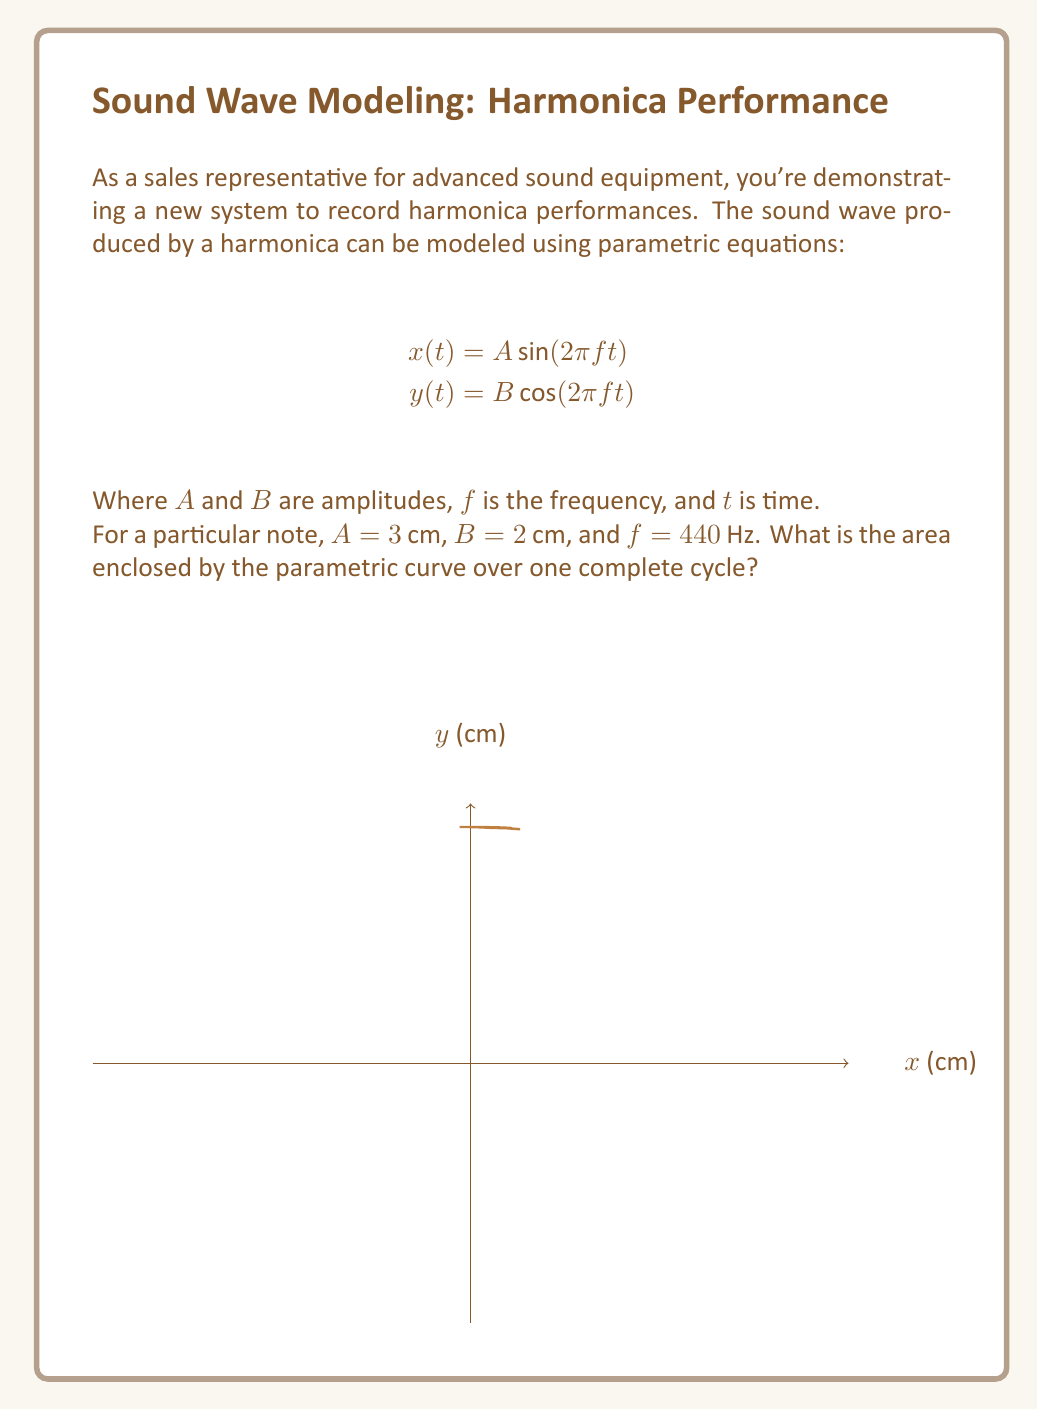Show me your answer to this math problem. Let's approach this step-by-step:

1) The parametric equations given are:
   $$x(t) = 3 \sin(2\pi 440 t)$$
   $$y(t) = 2 \cos(2\pi 440 t)$$

2) These equations describe an ellipse. The area of an ellipse is given by $\pi ab$, where $a$ and $b$ are the semi-major and semi-minor axes.

3) In this case, $a = 3$ cm and $b = 2$ cm.

4) Therefore, the area is:
   $$\text{Area} = \pi ab = \pi(3)(2) = 6\pi \text{ cm}^2$$

5) To verify, we can use the formula for the area enclosed by a parametric curve over one cycle:
   $$\text{Area} = \left|\frac{1}{2}\int_0^T (x\frac{dy}{dt} - y\frac{dx}{dt})dt\right|$$
   
   Where $T$ is the period of one cycle, which is $\frac{1}{f} = \frac{1}{440}$ seconds.

6) Calculating the derivatives:
   $$\frac{dx}{dt} = 3(2\pi 440)\cos(2\pi 440t)$$
   $$\frac{dy}{dt} = -2(2\pi 440)\sin(2\pi 440t)$$

7) Substituting into the integral:
   $$\text{Area} = \left|\frac{1}{2}\int_0^{\frac{1}{440}} (3\sin(2\pi 440t)(-2(2\pi 440)\sin(2\pi 440t)) - 2\cos(2\pi 440t)(3(2\pi 440)\cos(2\pi 440t)))dt\right|$$

8) Simplifying:
   $$\text{Area} = \left|\frac{1}{2}\int_0^{\frac{1}{440}} (-6(2\pi 440)\sin^2(2\pi 440t) - 6(2\pi 440)\cos^2(2\pi 440t))dt\right|$$
   $$= \left|-3(2\pi 440)\int_0^{\frac{1}{440}} (\sin^2(2\pi 440t) + \cos^2(2\pi 440t))dt\right|$$

9) Since $\sin^2(x) + \cos^2(x) = 1$, this simplifies to:
   $$\text{Area} = \left|-3(2\pi 440)\int_0^{\frac{1}{440}} dt\right| = 3(2\pi 440)(\frac{1}{440}) = 6\pi \text{ cm}^2$$

This confirms our initial calculation.
Answer: $6\pi \text{ cm}^2$ 